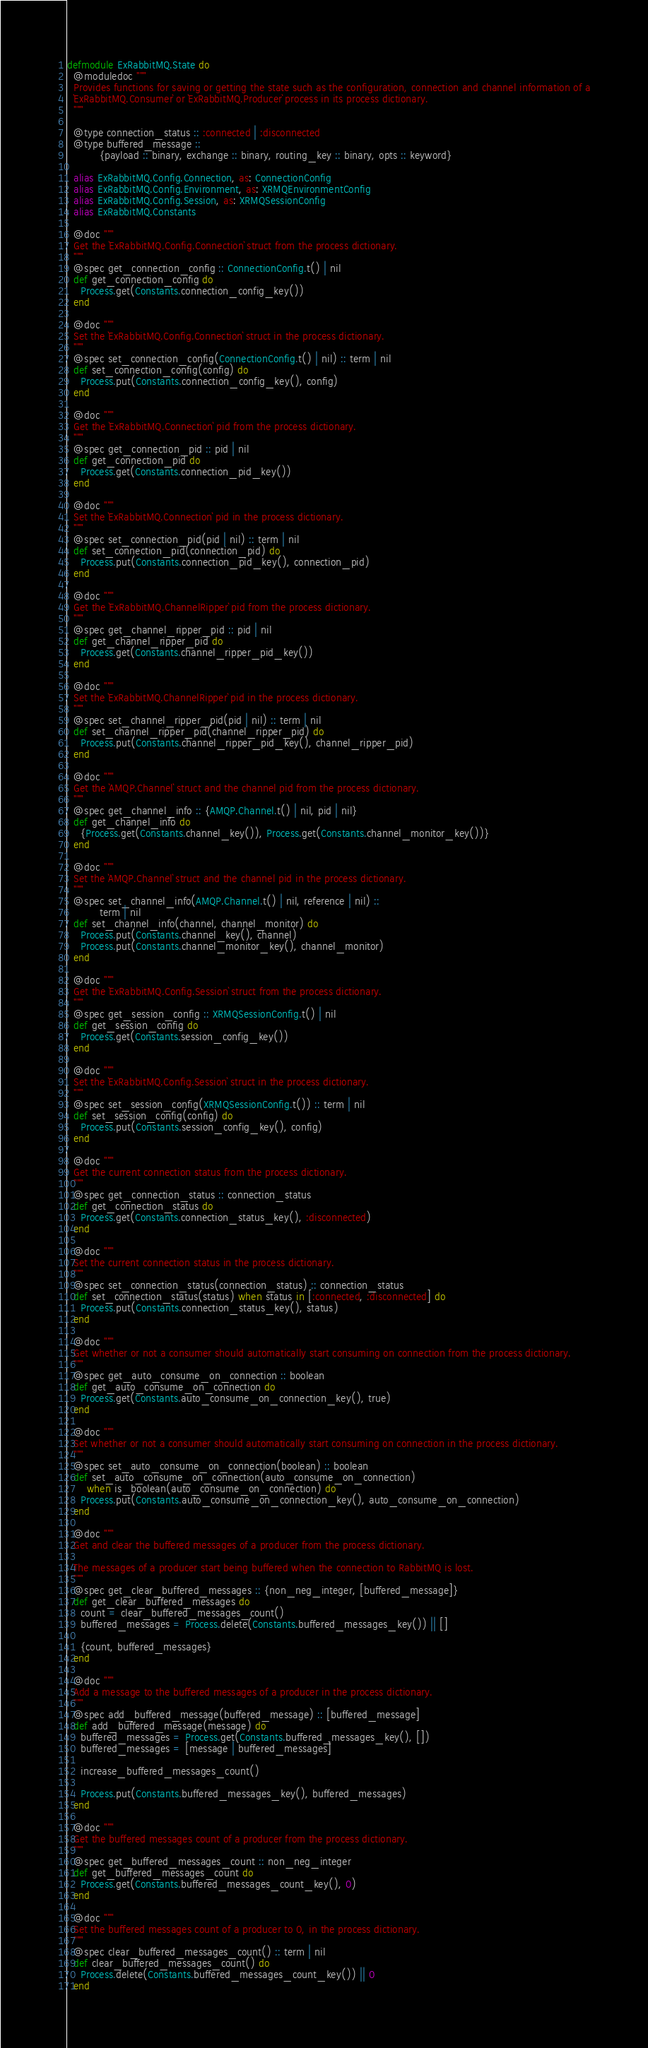Convert code to text. <code><loc_0><loc_0><loc_500><loc_500><_Elixir_>defmodule ExRabbitMQ.State do
  @moduledoc """
  Provides functions for saving or getting the state such as the configuration, connection and channel information of a
  `ExRabbitMQ.Consumer` or `ExRabbitMQ.Producer` process in its process dictionary.
  """

  @type connection_status :: :connected | :disconnected
  @type buffered_message ::
          {payload :: binary, exchange :: binary, routing_key :: binary, opts :: keyword}

  alias ExRabbitMQ.Config.Connection, as: ConnectionConfig
  alias ExRabbitMQ.Config.Environment, as: XRMQEnvironmentConfig
  alias ExRabbitMQ.Config.Session, as: XRMQSessionConfig
  alias ExRabbitMQ.Constants

  @doc """
  Get the `ExRabbitMQ.Config.Connection` struct from the process dictionary.
  """
  @spec get_connection_config :: ConnectionConfig.t() | nil
  def get_connection_config do
    Process.get(Constants.connection_config_key())
  end

  @doc """
  Set the `ExRabbitMQ.Config.Connection` struct in the process dictionary.
  """
  @spec set_connection_config(ConnectionConfig.t() | nil) :: term | nil
  def set_connection_config(config) do
    Process.put(Constants.connection_config_key(), config)
  end

  @doc """
  Get the `ExRabbitMQ.Connection` pid from the process dictionary.
  """
  @spec get_connection_pid :: pid | nil
  def get_connection_pid do
    Process.get(Constants.connection_pid_key())
  end

  @doc """
  Set the `ExRabbitMQ.Connection` pid in the process dictionary.
  """
  @spec set_connection_pid(pid | nil) :: term | nil
  def set_connection_pid(connection_pid) do
    Process.put(Constants.connection_pid_key(), connection_pid)
  end

  @doc """
  Get the `ExRabbitMQ.ChannelRipper` pid from the process dictionary.
  """
  @spec get_channel_ripper_pid :: pid | nil
  def get_channel_ripper_pid do
    Process.get(Constants.channel_ripper_pid_key())
  end

  @doc """
  Set the `ExRabbitMQ.ChannelRipper` pid in the process dictionary.
  """
  @spec set_channel_ripper_pid(pid | nil) :: term | nil
  def set_channel_ripper_pid(channel_ripper_pid) do
    Process.put(Constants.channel_ripper_pid_key(), channel_ripper_pid)
  end

  @doc """
  Get the `AMQP.Channel` struct and the channel pid from the process dictionary.
  """
  @spec get_channel_info :: {AMQP.Channel.t() | nil, pid | nil}
  def get_channel_info do
    {Process.get(Constants.channel_key()), Process.get(Constants.channel_monitor_key())}
  end

  @doc """
  Set the `AMQP.Channel` struct and the channel pid in the process dictionary.
  """
  @spec set_channel_info(AMQP.Channel.t() | nil, reference | nil) ::
          term | nil
  def set_channel_info(channel, channel_monitor) do
    Process.put(Constants.channel_key(), channel)
    Process.put(Constants.channel_monitor_key(), channel_monitor)
  end

  @doc """
  Get the `ExRabbitMQ.Config.Session` struct from the process dictionary.
  """
  @spec get_session_config :: XRMQSessionConfig.t() | nil
  def get_session_config do
    Process.get(Constants.session_config_key())
  end

  @doc """
  Set the `ExRabbitMQ.Config.Session` struct in the process dictionary.
  """
  @spec set_session_config(XRMQSessionConfig.t()) :: term | nil
  def set_session_config(config) do
    Process.put(Constants.session_config_key(), config)
  end

  @doc """
  Get the current connection status from the process dictionary.
  """
  @spec get_connection_status :: connection_status
  def get_connection_status do
    Process.get(Constants.connection_status_key(), :disconnected)
  end

  @doc """
  Set the current connection status in the process dictionary.
  """
  @spec set_connection_status(connection_status) :: connection_status
  def set_connection_status(status) when status in [:connected, :disconnected] do
    Process.put(Constants.connection_status_key(), status)
  end

  @doc """
  Get whether or not a consumer should automatically start consuming on connection from the process dictionary.
  """
  @spec get_auto_consume_on_connection :: boolean
  def get_auto_consume_on_connection do
    Process.get(Constants.auto_consume_on_connection_key(), true)
  end

  @doc """
  Set whether or not a consumer should automatically start consuming on connection in the process dictionary.
  """
  @spec set_auto_consume_on_connection(boolean) :: boolean
  def set_auto_consume_on_connection(auto_consume_on_connection)
      when is_boolean(auto_consume_on_connection) do
    Process.put(Constants.auto_consume_on_connection_key(), auto_consume_on_connection)
  end

  @doc """
  Get and clear the buffered messages of a producer from the process dictionary.

  The messages of a producer start being buffered when the connection to RabbitMQ is lost.
  """
  @spec get_clear_buffered_messages :: {non_neg_integer, [buffered_message]}
  def get_clear_buffered_messages do
    count = clear_buffered_messages_count()
    buffered_messages = Process.delete(Constants.buffered_messages_key()) || []

    {count, buffered_messages}
  end

  @doc """
  Add a message to the buffered messages of a producer in the process dictionary.
  """
  @spec add_buffered_message(buffered_message) :: [buffered_message]
  def add_buffered_message(message) do
    buffered_messages = Process.get(Constants.buffered_messages_key(), [])
    buffered_messages = [message | buffered_messages]

    increase_buffered_messages_count()

    Process.put(Constants.buffered_messages_key(), buffered_messages)
  end

  @doc """
  Get the buffered messages count of a producer from the process dictionary.
  """
  @spec get_buffered_messages_count :: non_neg_integer
  def get_buffered_messages_count do
    Process.get(Constants.buffered_messages_count_key(), 0)
  end

  @doc """
  Set the buffered messages count of a producer to 0, in the process dictionary.
  """
  @spec clear_buffered_messages_count() :: term | nil
  def clear_buffered_messages_count() do
    Process.delete(Constants.buffered_messages_count_key()) || 0
  end
</code> 